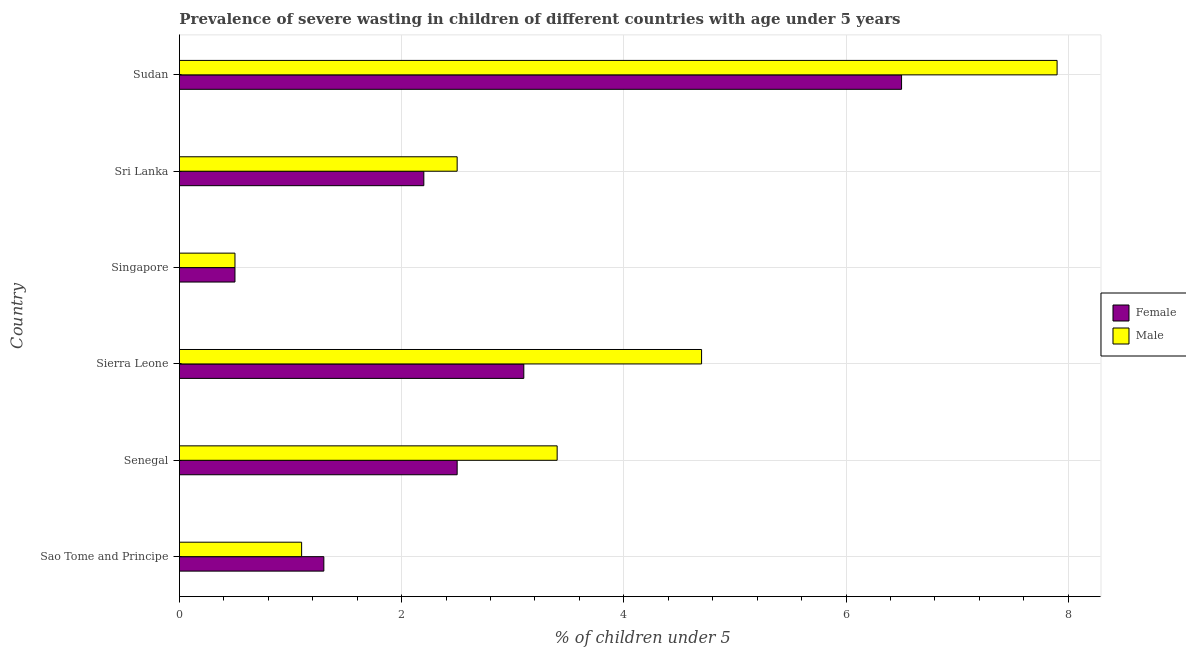Are the number of bars per tick equal to the number of legend labels?
Offer a terse response. Yes. Are the number of bars on each tick of the Y-axis equal?
Make the answer very short. Yes. How many bars are there on the 3rd tick from the bottom?
Offer a very short reply. 2. What is the label of the 2nd group of bars from the top?
Your response must be concise. Sri Lanka. In how many cases, is the number of bars for a given country not equal to the number of legend labels?
Make the answer very short. 0. What is the percentage of undernourished male children in Sierra Leone?
Offer a very short reply. 4.7. Across all countries, what is the maximum percentage of undernourished male children?
Ensure brevity in your answer.  7.9. Across all countries, what is the minimum percentage of undernourished male children?
Offer a very short reply. 0.5. In which country was the percentage of undernourished female children maximum?
Your answer should be compact. Sudan. In which country was the percentage of undernourished female children minimum?
Make the answer very short. Singapore. What is the total percentage of undernourished male children in the graph?
Provide a short and direct response. 20.1. What is the difference between the percentage of undernourished female children in Sao Tome and Principe and that in Sudan?
Your response must be concise. -5.2. What is the average percentage of undernourished male children per country?
Provide a succinct answer. 3.35. What is the ratio of the percentage of undernourished male children in Sao Tome and Principe to that in Singapore?
Your answer should be compact. 2.2. Is the difference between the percentage of undernourished male children in Sierra Leone and Sudan greater than the difference between the percentage of undernourished female children in Sierra Leone and Sudan?
Your response must be concise. Yes. What is the difference between the highest and the lowest percentage of undernourished female children?
Give a very brief answer. 6. In how many countries, is the percentage of undernourished female children greater than the average percentage of undernourished female children taken over all countries?
Keep it short and to the point. 2. Is the sum of the percentage of undernourished female children in Sierra Leone and Sri Lanka greater than the maximum percentage of undernourished male children across all countries?
Provide a succinct answer. No. How many bars are there?
Keep it short and to the point. 12. Are all the bars in the graph horizontal?
Offer a very short reply. Yes. How many countries are there in the graph?
Give a very brief answer. 6. What is the difference between two consecutive major ticks on the X-axis?
Your response must be concise. 2. Are the values on the major ticks of X-axis written in scientific E-notation?
Keep it short and to the point. No. Where does the legend appear in the graph?
Your answer should be compact. Center right. How many legend labels are there?
Provide a short and direct response. 2. What is the title of the graph?
Keep it short and to the point. Prevalence of severe wasting in children of different countries with age under 5 years. Does "Primary income" appear as one of the legend labels in the graph?
Your response must be concise. No. What is the label or title of the X-axis?
Make the answer very short.  % of children under 5. What is the  % of children under 5 of Female in Sao Tome and Principe?
Offer a very short reply. 1.3. What is the  % of children under 5 in Male in Sao Tome and Principe?
Offer a very short reply. 1.1. What is the  % of children under 5 in Female in Senegal?
Ensure brevity in your answer.  2.5. What is the  % of children under 5 of Male in Senegal?
Provide a short and direct response. 3.4. What is the  % of children under 5 in Female in Sierra Leone?
Make the answer very short. 3.1. What is the  % of children under 5 in Male in Sierra Leone?
Your answer should be very brief. 4.7. What is the  % of children under 5 of Female in Singapore?
Your response must be concise. 0.5. What is the  % of children under 5 in Female in Sri Lanka?
Provide a short and direct response. 2.2. What is the  % of children under 5 in Female in Sudan?
Your answer should be compact. 6.5. What is the  % of children under 5 in Male in Sudan?
Ensure brevity in your answer.  7.9. Across all countries, what is the maximum  % of children under 5 of Male?
Give a very brief answer. 7.9. Across all countries, what is the minimum  % of children under 5 in Male?
Give a very brief answer. 0.5. What is the total  % of children under 5 of Female in the graph?
Your answer should be very brief. 16.1. What is the total  % of children under 5 in Male in the graph?
Your answer should be compact. 20.1. What is the difference between the  % of children under 5 of Female in Sao Tome and Principe and that in Senegal?
Your response must be concise. -1.2. What is the difference between the  % of children under 5 in Male in Sao Tome and Principe and that in Sierra Leone?
Ensure brevity in your answer.  -3.6. What is the difference between the  % of children under 5 in Male in Sao Tome and Principe and that in Singapore?
Make the answer very short. 0.6. What is the difference between the  % of children under 5 of Female in Sao Tome and Principe and that in Sudan?
Offer a very short reply. -5.2. What is the difference between the  % of children under 5 of Male in Sao Tome and Principe and that in Sudan?
Provide a succinct answer. -6.8. What is the difference between the  % of children under 5 of Female in Senegal and that in Singapore?
Provide a short and direct response. 2. What is the difference between the  % of children under 5 in Male in Senegal and that in Singapore?
Offer a very short reply. 2.9. What is the difference between the  % of children under 5 of Male in Senegal and that in Sri Lanka?
Give a very brief answer. 0.9. What is the difference between the  % of children under 5 in Female in Sierra Leone and that in Sri Lanka?
Your answer should be very brief. 0.9. What is the difference between the  % of children under 5 of Male in Sierra Leone and that in Sri Lanka?
Give a very brief answer. 2.2. What is the difference between the  % of children under 5 of Male in Sierra Leone and that in Sudan?
Offer a very short reply. -3.2. What is the difference between the  % of children under 5 in Male in Singapore and that in Sri Lanka?
Offer a terse response. -2. What is the difference between the  % of children under 5 of Female in Singapore and that in Sudan?
Give a very brief answer. -6. What is the difference between the  % of children under 5 of Female in Sao Tome and Principe and the  % of children under 5 of Male in Senegal?
Your response must be concise. -2.1. What is the difference between the  % of children under 5 in Female in Sao Tome and Principe and the  % of children under 5 in Male in Singapore?
Your answer should be compact. 0.8. What is the difference between the  % of children under 5 in Female in Sao Tome and Principe and the  % of children under 5 in Male in Sudan?
Offer a terse response. -6.6. What is the difference between the  % of children under 5 of Female in Senegal and the  % of children under 5 of Male in Sierra Leone?
Make the answer very short. -2.2. What is the difference between the  % of children under 5 of Female in Senegal and the  % of children under 5 of Male in Singapore?
Your answer should be compact. 2. What is the difference between the  % of children under 5 in Female in Sierra Leone and the  % of children under 5 in Male in Singapore?
Provide a succinct answer. 2.6. What is the difference between the  % of children under 5 of Female in Sierra Leone and the  % of children under 5 of Male in Sudan?
Offer a very short reply. -4.8. What is the difference between the  % of children under 5 of Female in Singapore and the  % of children under 5 of Male in Sri Lanka?
Your response must be concise. -2. What is the difference between the  % of children under 5 in Female in Singapore and the  % of children under 5 in Male in Sudan?
Provide a succinct answer. -7.4. What is the difference between the  % of children under 5 of Female in Sri Lanka and the  % of children under 5 of Male in Sudan?
Provide a short and direct response. -5.7. What is the average  % of children under 5 of Female per country?
Offer a very short reply. 2.68. What is the average  % of children under 5 in Male per country?
Ensure brevity in your answer.  3.35. What is the difference between the  % of children under 5 in Female and  % of children under 5 in Male in Sao Tome and Principe?
Make the answer very short. 0.2. What is the difference between the  % of children under 5 of Female and  % of children under 5 of Male in Sierra Leone?
Your answer should be very brief. -1.6. What is the difference between the  % of children under 5 of Female and  % of children under 5 of Male in Singapore?
Make the answer very short. 0. What is the difference between the  % of children under 5 of Female and  % of children under 5 of Male in Sudan?
Make the answer very short. -1.4. What is the ratio of the  % of children under 5 in Female in Sao Tome and Principe to that in Senegal?
Keep it short and to the point. 0.52. What is the ratio of the  % of children under 5 of Male in Sao Tome and Principe to that in Senegal?
Provide a succinct answer. 0.32. What is the ratio of the  % of children under 5 of Female in Sao Tome and Principe to that in Sierra Leone?
Make the answer very short. 0.42. What is the ratio of the  % of children under 5 of Male in Sao Tome and Principe to that in Sierra Leone?
Your answer should be very brief. 0.23. What is the ratio of the  % of children under 5 of Female in Sao Tome and Principe to that in Sri Lanka?
Your answer should be very brief. 0.59. What is the ratio of the  % of children under 5 of Male in Sao Tome and Principe to that in Sri Lanka?
Your response must be concise. 0.44. What is the ratio of the  % of children under 5 of Female in Sao Tome and Principe to that in Sudan?
Ensure brevity in your answer.  0.2. What is the ratio of the  % of children under 5 of Male in Sao Tome and Principe to that in Sudan?
Provide a succinct answer. 0.14. What is the ratio of the  % of children under 5 of Female in Senegal to that in Sierra Leone?
Offer a very short reply. 0.81. What is the ratio of the  % of children under 5 in Male in Senegal to that in Sierra Leone?
Offer a very short reply. 0.72. What is the ratio of the  % of children under 5 in Female in Senegal to that in Singapore?
Keep it short and to the point. 5. What is the ratio of the  % of children under 5 in Male in Senegal to that in Singapore?
Keep it short and to the point. 6.8. What is the ratio of the  % of children under 5 in Female in Senegal to that in Sri Lanka?
Offer a terse response. 1.14. What is the ratio of the  % of children under 5 in Male in Senegal to that in Sri Lanka?
Make the answer very short. 1.36. What is the ratio of the  % of children under 5 of Female in Senegal to that in Sudan?
Ensure brevity in your answer.  0.38. What is the ratio of the  % of children under 5 in Male in Senegal to that in Sudan?
Offer a terse response. 0.43. What is the ratio of the  % of children under 5 in Female in Sierra Leone to that in Singapore?
Provide a succinct answer. 6.2. What is the ratio of the  % of children under 5 in Male in Sierra Leone to that in Singapore?
Provide a short and direct response. 9.4. What is the ratio of the  % of children under 5 of Female in Sierra Leone to that in Sri Lanka?
Your response must be concise. 1.41. What is the ratio of the  % of children under 5 of Male in Sierra Leone to that in Sri Lanka?
Your response must be concise. 1.88. What is the ratio of the  % of children under 5 in Female in Sierra Leone to that in Sudan?
Provide a succinct answer. 0.48. What is the ratio of the  % of children under 5 of Male in Sierra Leone to that in Sudan?
Give a very brief answer. 0.59. What is the ratio of the  % of children under 5 in Female in Singapore to that in Sri Lanka?
Make the answer very short. 0.23. What is the ratio of the  % of children under 5 in Male in Singapore to that in Sri Lanka?
Keep it short and to the point. 0.2. What is the ratio of the  % of children under 5 in Female in Singapore to that in Sudan?
Give a very brief answer. 0.08. What is the ratio of the  % of children under 5 of Male in Singapore to that in Sudan?
Ensure brevity in your answer.  0.06. What is the ratio of the  % of children under 5 in Female in Sri Lanka to that in Sudan?
Offer a very short reply. 0.34. What is the ratio of the  % of children under 5 in Male in Sri Lanka to that in Sudan?
Provide a short and direct response. 0.32. 